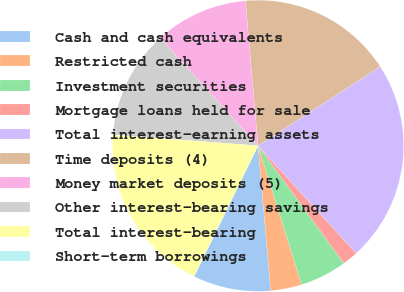<chart> <loc_0><loc_0><loc_500><loc_500><pie_chart><fcel>Cash and cash equivalents<fcel>Restricted cash<fcel>Investment securities<fcel>Mortgage loans held for sale<fcel>Total interest-earning assets<fcel>Time deposits (4)<fcel>Money market deposits (5)<fcel>Other interest-bearing savings<fcel>Total interest-bearing<fcel>Short-term borrowings<nl><fcel>8.62%<fcel>3.46%<fcel>5.18%<fcel>1.74%<fcel>22.38%<fcel>17.22%<fcel>10.34%<fcel>12.06%<fcel>18.94%<fcel>0.02%<nl></chart> 